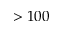Convert formula to latex. <formula><loc_0><loc_0><loc_500><loc_500>> 1 0 0</formula> 